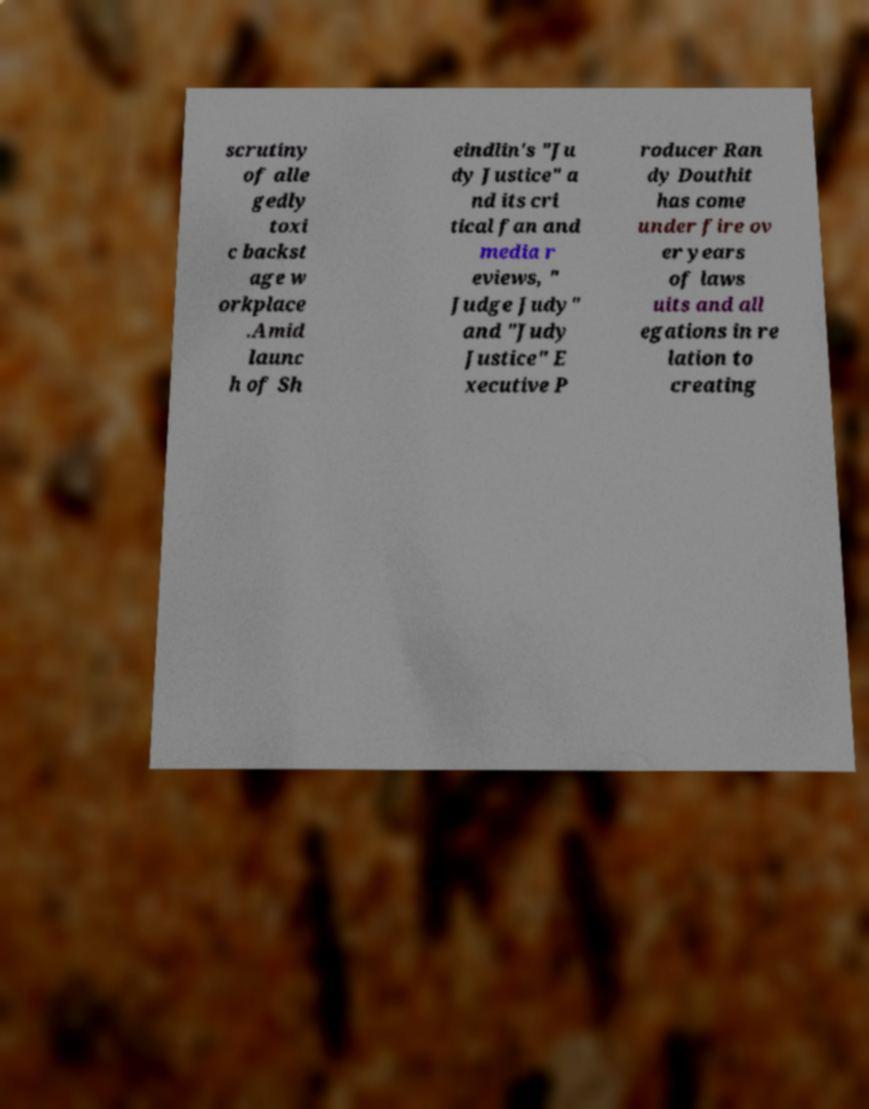Can you accurately transcribe the text from the provided image for me? scrutiny of alle gedly toxi c backst age w orkplace .Amid launc h of Sh eindlin's "Ju dy Justice" a nd its cri tical fan and media r eviews, " Judge Judy" and "Judy Justice" E xecutive P roducer Ran dy Douthit has come under fire ov er years of laws uits and all egations in re lation to creating 